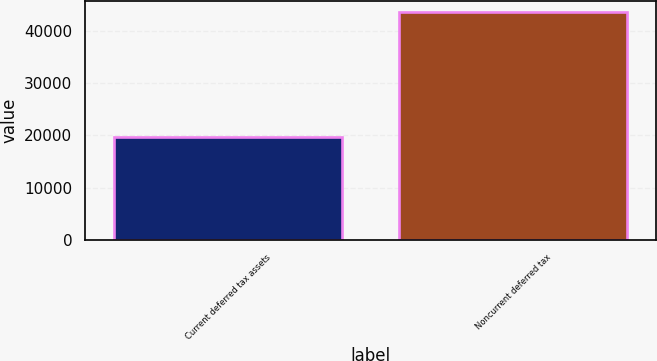Convert chart to OTSL. <chart><loc_0><loc_0><loc_500><loc_500><bar_chart><fcel>Current deferred tax assets<fcel>Noncurrent deferred tax<nl><fcel>19644<fcel>43518<nl></chart> 